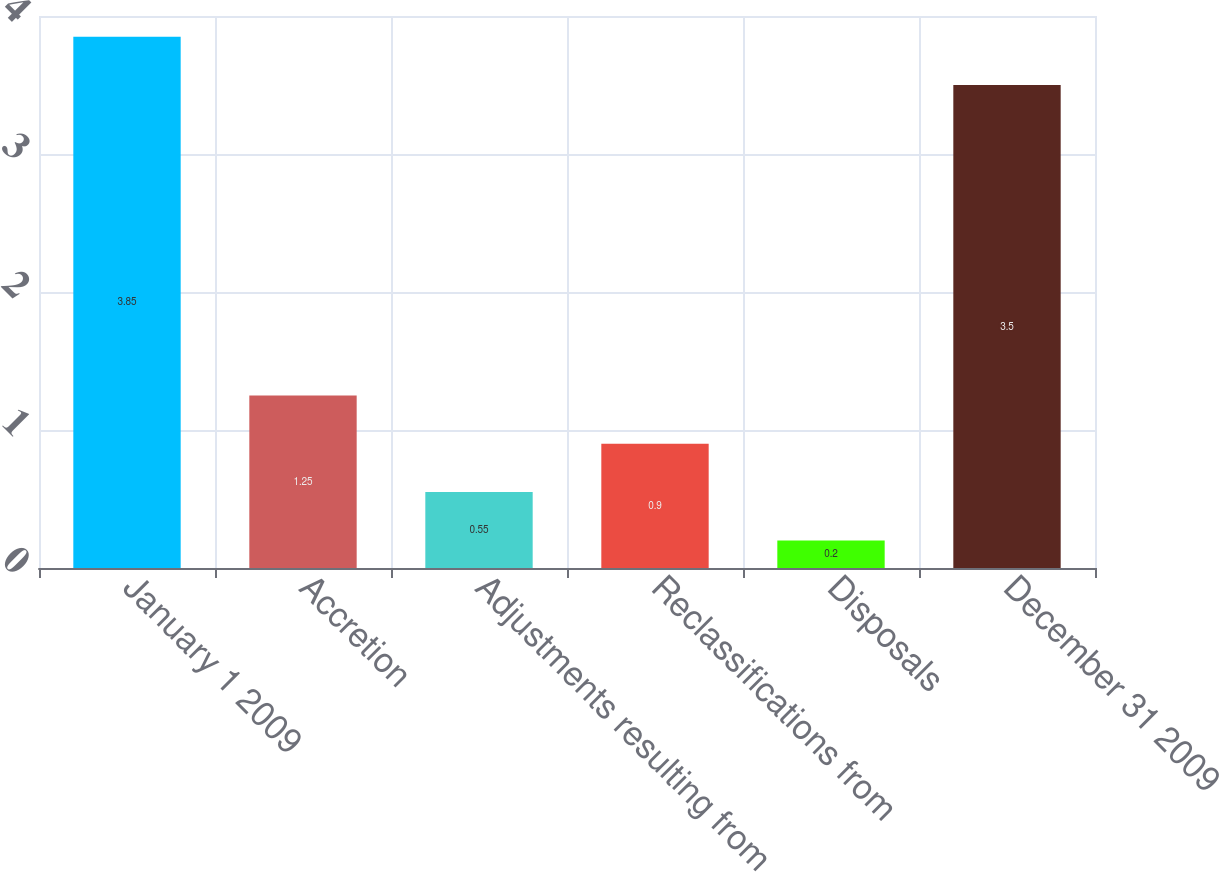<chart> <loc_0><loc_0><loc_500><loc_500><bar_chart><fcel>January 1 2009<fcel>Accretion<fcel>Adjustments resulting from<fcel>Reclassifications from<fcel>Disposals<fcel>December 31 2009<nl><fcel>3.85<fcel>1.25<fcel>0.55<fcel>0.9<fcel>0.2<fcel>3.5<nl></chart> 